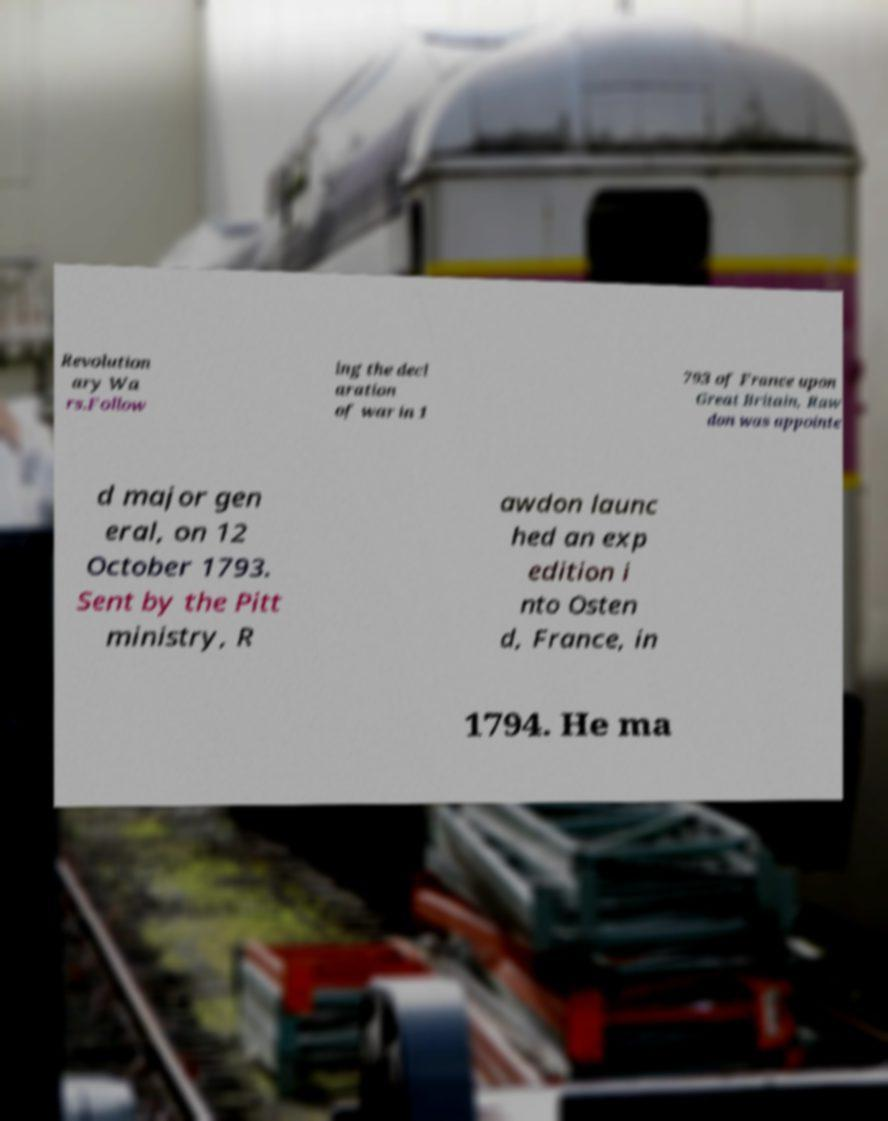I need the written content from this picture converted into text. Can you do that? Revolution ary Wa rs.Follow ing the decl aration of war in 1 793 of France upon Great Britain, Raw don was appointe d major gen eral, on 12 October 1793. Sent by the Pitt ministry, R awdon launc hed an exp edition i nto Osten d, France, in 1794. He ma 